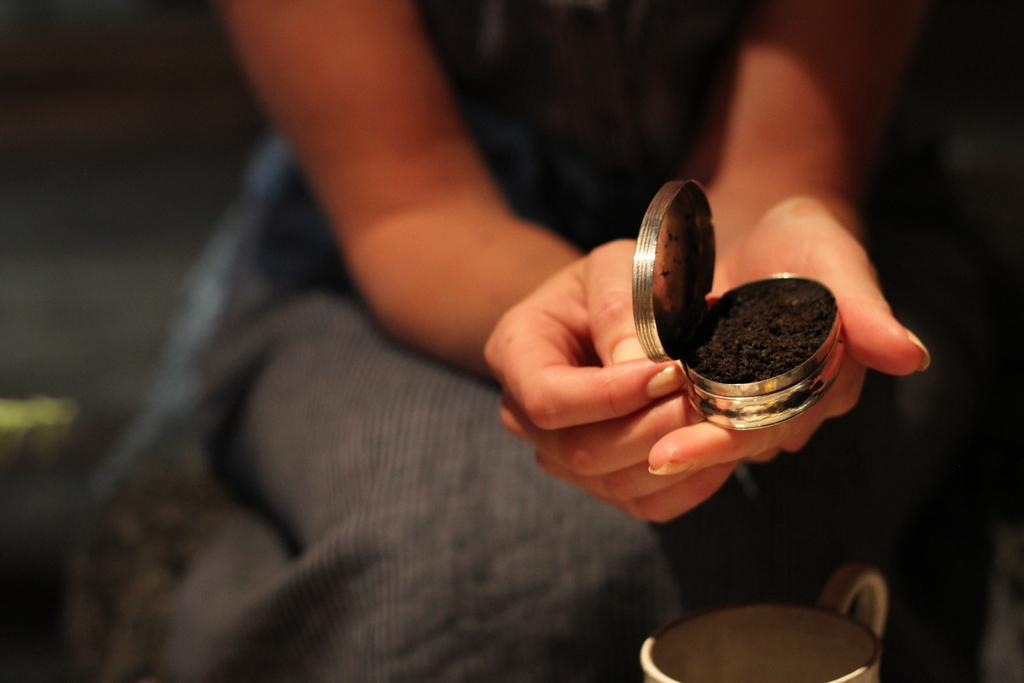Who is the main subject in the image? There is a woman in the image. What is the woman holding in the image? The woman is holding a small box. What is inside the box that the woman is holding? The box contains black-colored powder. What other object can be seen at the bottom of the image? There is a cup at the bottom of the image. Where is the garden located in the image? There is no garden present in the image. What type of doctor is standing next to the woman in the image? There is no doctor present in the image. 